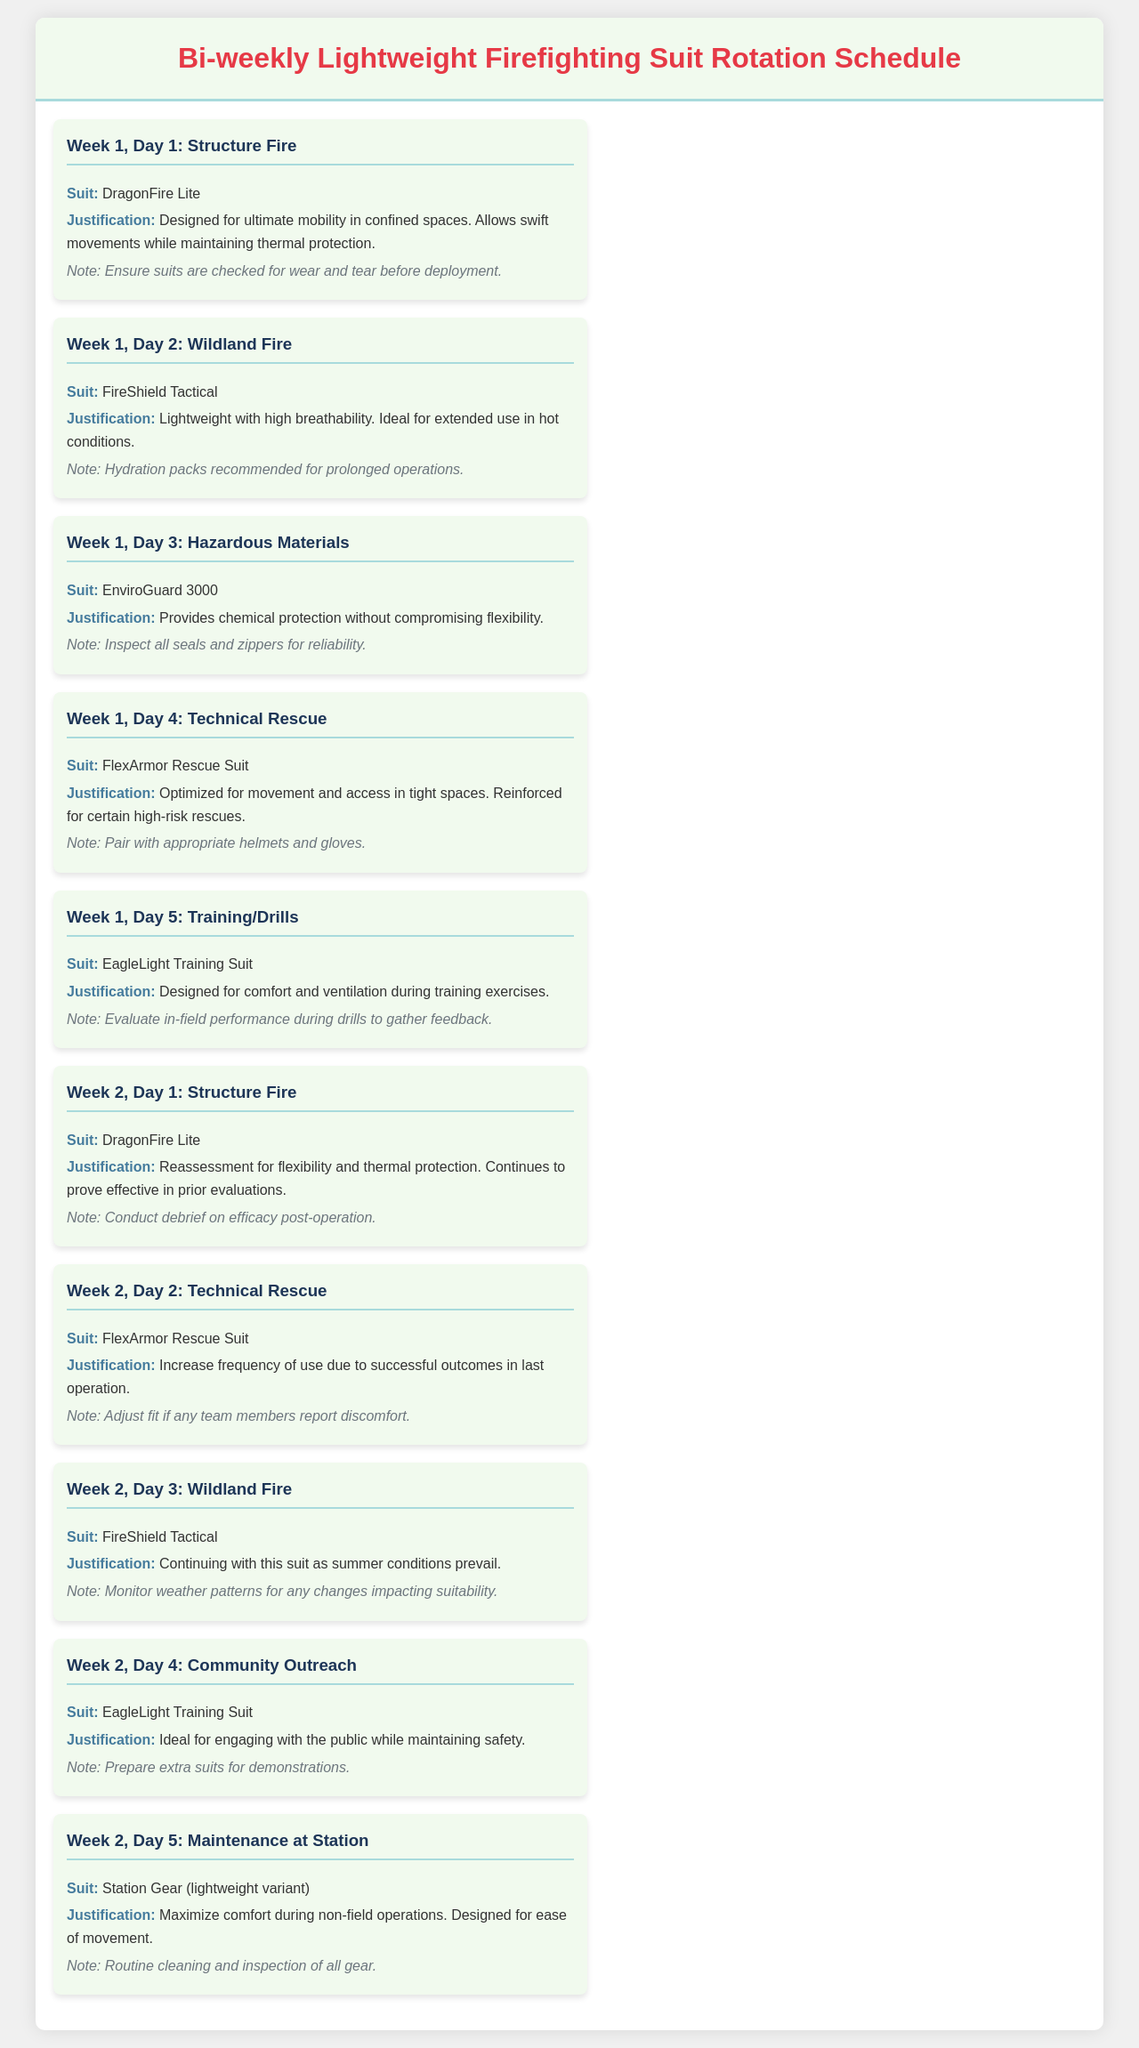What suit is used for Structure Fire on Week 1, Day 1? The suit specified for Structure Fire on Week 1, Day 1 is listed in the document.
Answer: DragonFire Lite What is the justification for using FireShield Tactical? The justification for FireShield Tactical is provided in the document.
Answer: Lightweight with high breathability How many days does the schedule cover in total? The schedule shows operations for two weeks with five days each week.
Answer: 10 days Which suit is recommended for Technical Rescue on Week 2, Day 2? The suit for Technical Rescue on that specific day is clearly mentioned in the document.
Answer: FlexArmor Rescue Suit What should be paired with the FlexArmor Rescue Suit? The document includes recommended equipment to be used with the suit.
Answer: Appropriate helmets and gloves On what day is maintenance scheduled at the station? The specific day for maintenance at the station is clearly stated in the document.
Answer: Week 2, Day 5 What additional gear is suggested for prolonged operations? The document mentions recommended gear for specific situations.
Answer: Hydration packs How often is the DragonFire Lite suit assessed? The assessment frequency for the suit is indicated in the document.
Answer: Bi-weekly What is the color theme of the document header? The document describes the color used in the header.
Answer: Red 